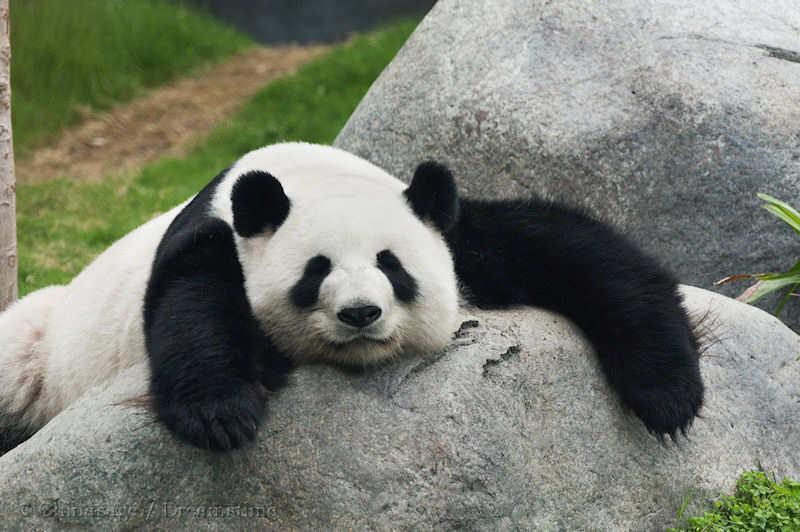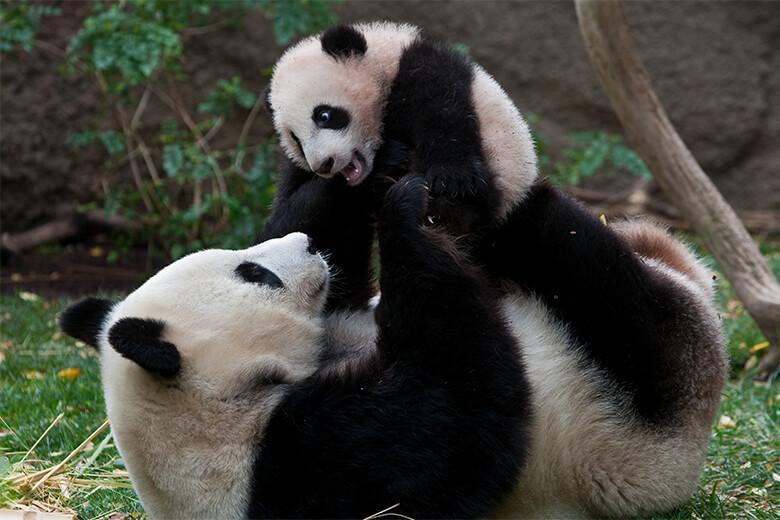The first image is the image on the left, the second image is the image on the right. Examine the images to the left and right. Is the description "There are a total of three panda bears in these images." accurate? Answer yes or no. Yes. The first image is the image on the left, the second image is the image on the right. Given the left and right images, does the statement "A panda has its chin on a surface." hold true? Answer yes or no. Yes. The first image is the image on the left, the second image is the image on the right. Evaluate the accuracy of this statement regarding the images: "There are three panda bears". Is it true? Answer yes or no. Yes. 